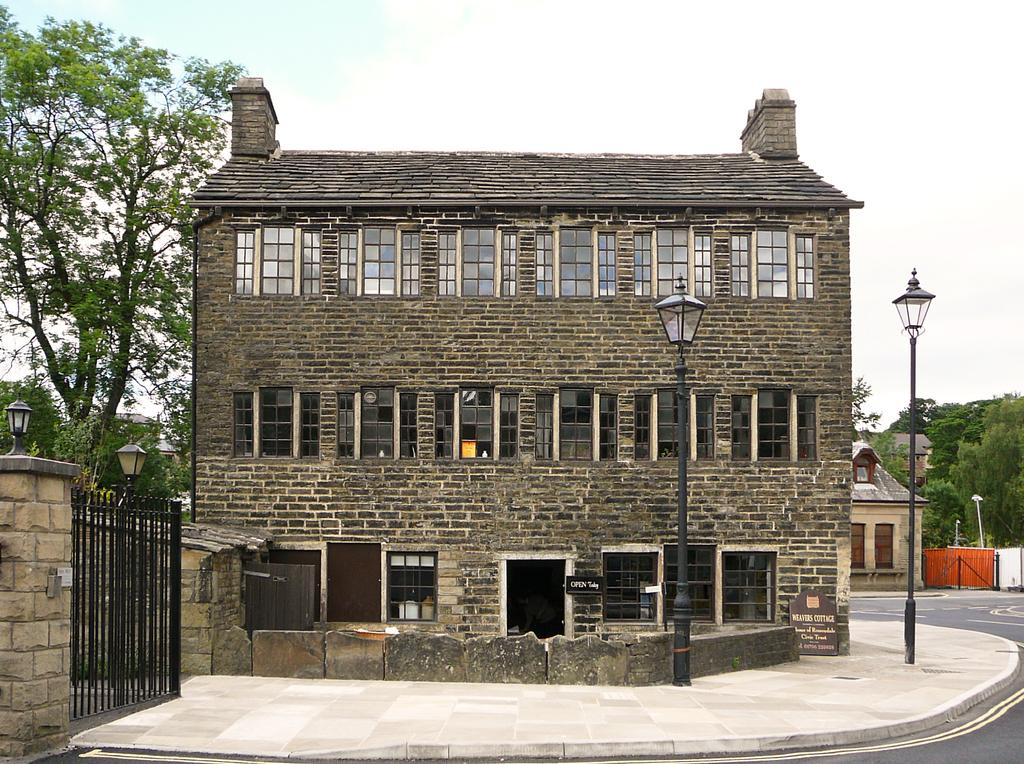What types of structures are visible in the image? There are buildings in the image. What type of vegetation can be seen in the image? There are trees in the image. What architectural features are present in the image? There are gates, doors, and windows in the image. What other objects can be seen in the image? There are poles and lights in the image. What is visible in the background of the image? The sky is visible in the background of the image. What type of pest can be seen crawling on the buildings in the image? There are no pests visible in the image; it only features buildings, trees, gates, doors, windows, poles, lights, and the sky. What color is the brass on the gates in the image? There is no brass present on the gates in the image; the gates are made of other materials. 